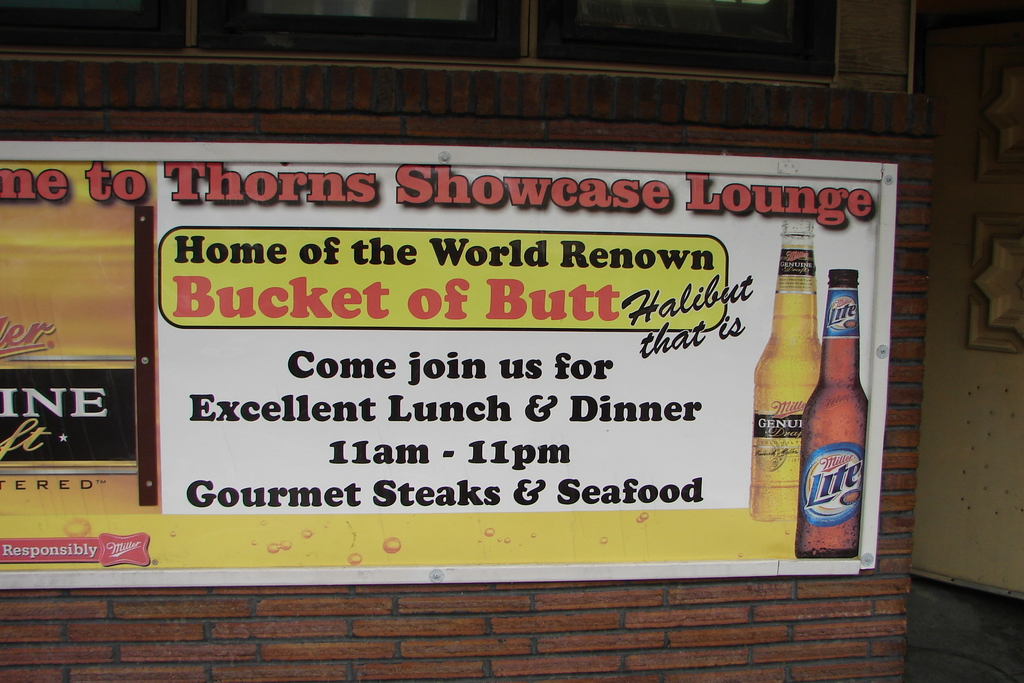What is this photo about? This photo features the charming advertisement sign of Thorns Showcase Lounge, known for its 'Bucket of Butt Halibut.' It beckons visitors to enjoy not only their famous halibut but also gourmet steaks and seafood from 11am to 11pm daily. The design of the sign, with its vibrant colors and playful use of a Miller Lite beer bottle graphic, suggests a casual and inviting dining atmosphere, likely appealing to a wide range of diners looking for quality meals in a relaxed setting. 